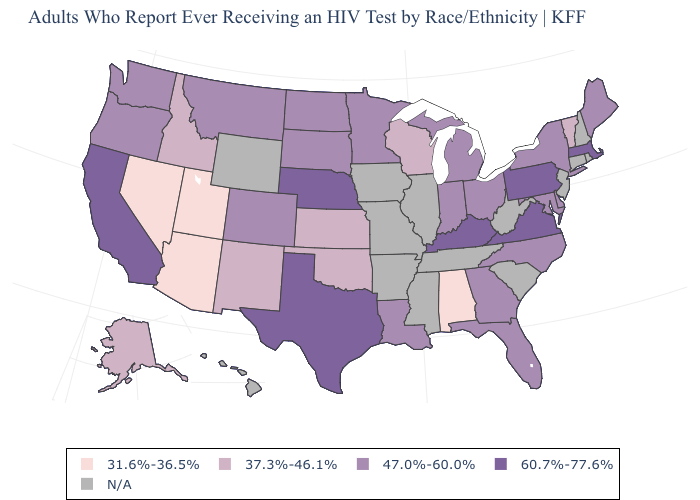What is the lowest value in the USA?
Answer briefly. 31.6%-36.5%. What is the value of Texas?
Concise answer only. 60.7%-77.6%. Among the states that border Arizona , which have the highest value?
Give a very brief answer. California. How many symbols are there in the legend?
Answer briefly. 5. Among the states that border Arkansas , does Louisiana have the lowest value?
Write a very short answer. No. Which states hav the highest value in the West?
Be succinct. California. Does Alabama have the highest value in the South?
Short answer required. No. Does Georgia have the lowest value in the USA?
Be succinct. No. Name the states that have a value in the range 31.6%-36.5%?
Short answer required. Alabama, Arizona, Nevada, Utah. Name the states that have a value in the range 60.7%-77.6%?
Short answer required. California, Kentucky, Massachusetts, Nebraska, Pennsylvania, Texas, Virginia. Does the map have missing data?
Give a very brief answer. Yes. What is the value of Wisconsin?
Keep it brief. 37.3%-46.1%. Name the states that have a value in the range 31.6%-36.5%?
Answer briefly. Alabama, Arizona, Nevada, Utah. What is the value of California?
Quick response, please. 60.7%-77.6%. What is the value of Kentucky?
Quick response, please. 60.7%-77.6%. 